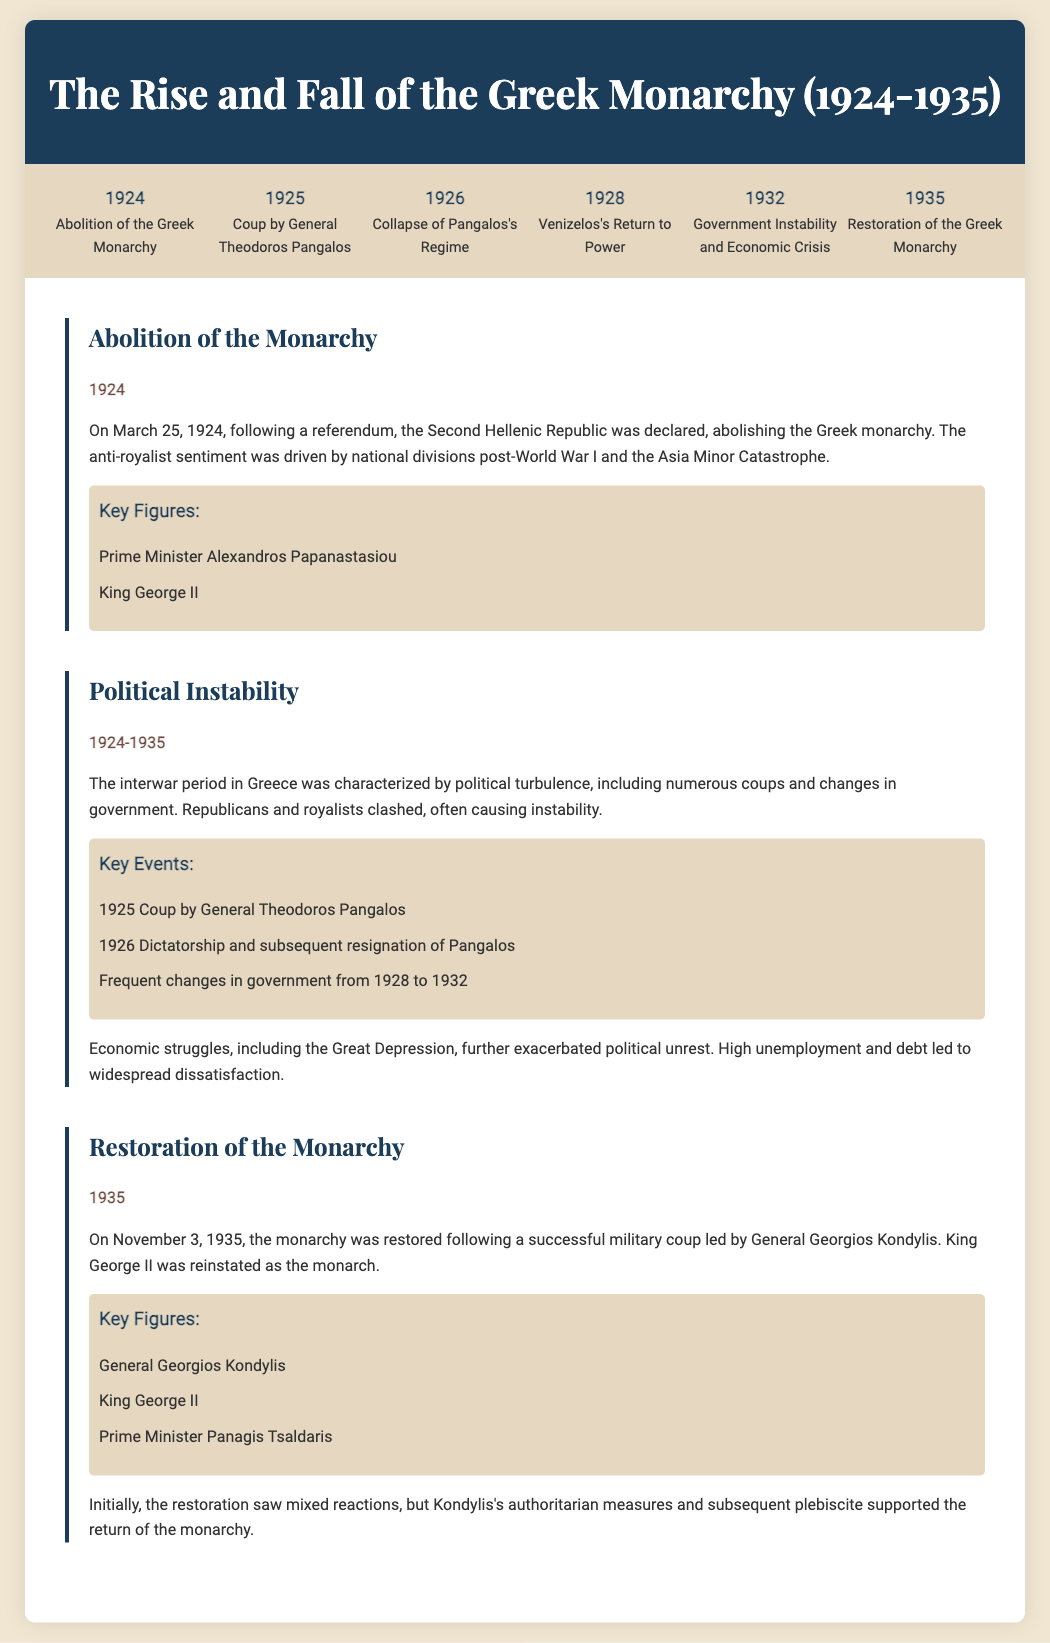What year was the Greek monarchy abolished? The document states that the Greek monarchy was abolished in 1924 as part of the declaration of the Second Hellenic Republic.
Answer: 1924 Who led the coup in 1925? The document specifies that General Theodoros Pangalos was the leader of the coup in 1925.
Answer: General Theodoros Pangalos What major event occurred in 1932? The timeline indicates that there was government instability and an economic crisis in 1932.
Answer: Government Instability and Economic Crisis What was the outcome of the coup led by General Georgios Kondylis in 1935? According to the document, the outcome was the restoration of the Greek monarchy.
Answer: Restoration of the Greek Monarchy Who was the monarch during the restoration in 1935? The document identifies King George II as the monarch who was reinstated during the restoration.
Answer: King George II What sentiment led to the abolition of the monarchy? The information implies that the anti-royalist sentiment was driven by national divisions post-World War I and the Asia Minor Catastrophe.
Answer: Anti-royalist sentiment How many key figures are listed for the restoration section? The section on the restoration lists three key figures involved in the 1935 events.
Answer: Three What was a significant impact of the Great Depression on Greece? The document outlines that the Great Depression led to widespread dissatisfaction due to high unemployment and debt, contributing to political unrest.
Answer: Widespread dissatisfaction Which political leader's return to power is highlighted in 1928? The document mentions that Venizelos returned to power in 1928.
Answer: Venizelos 